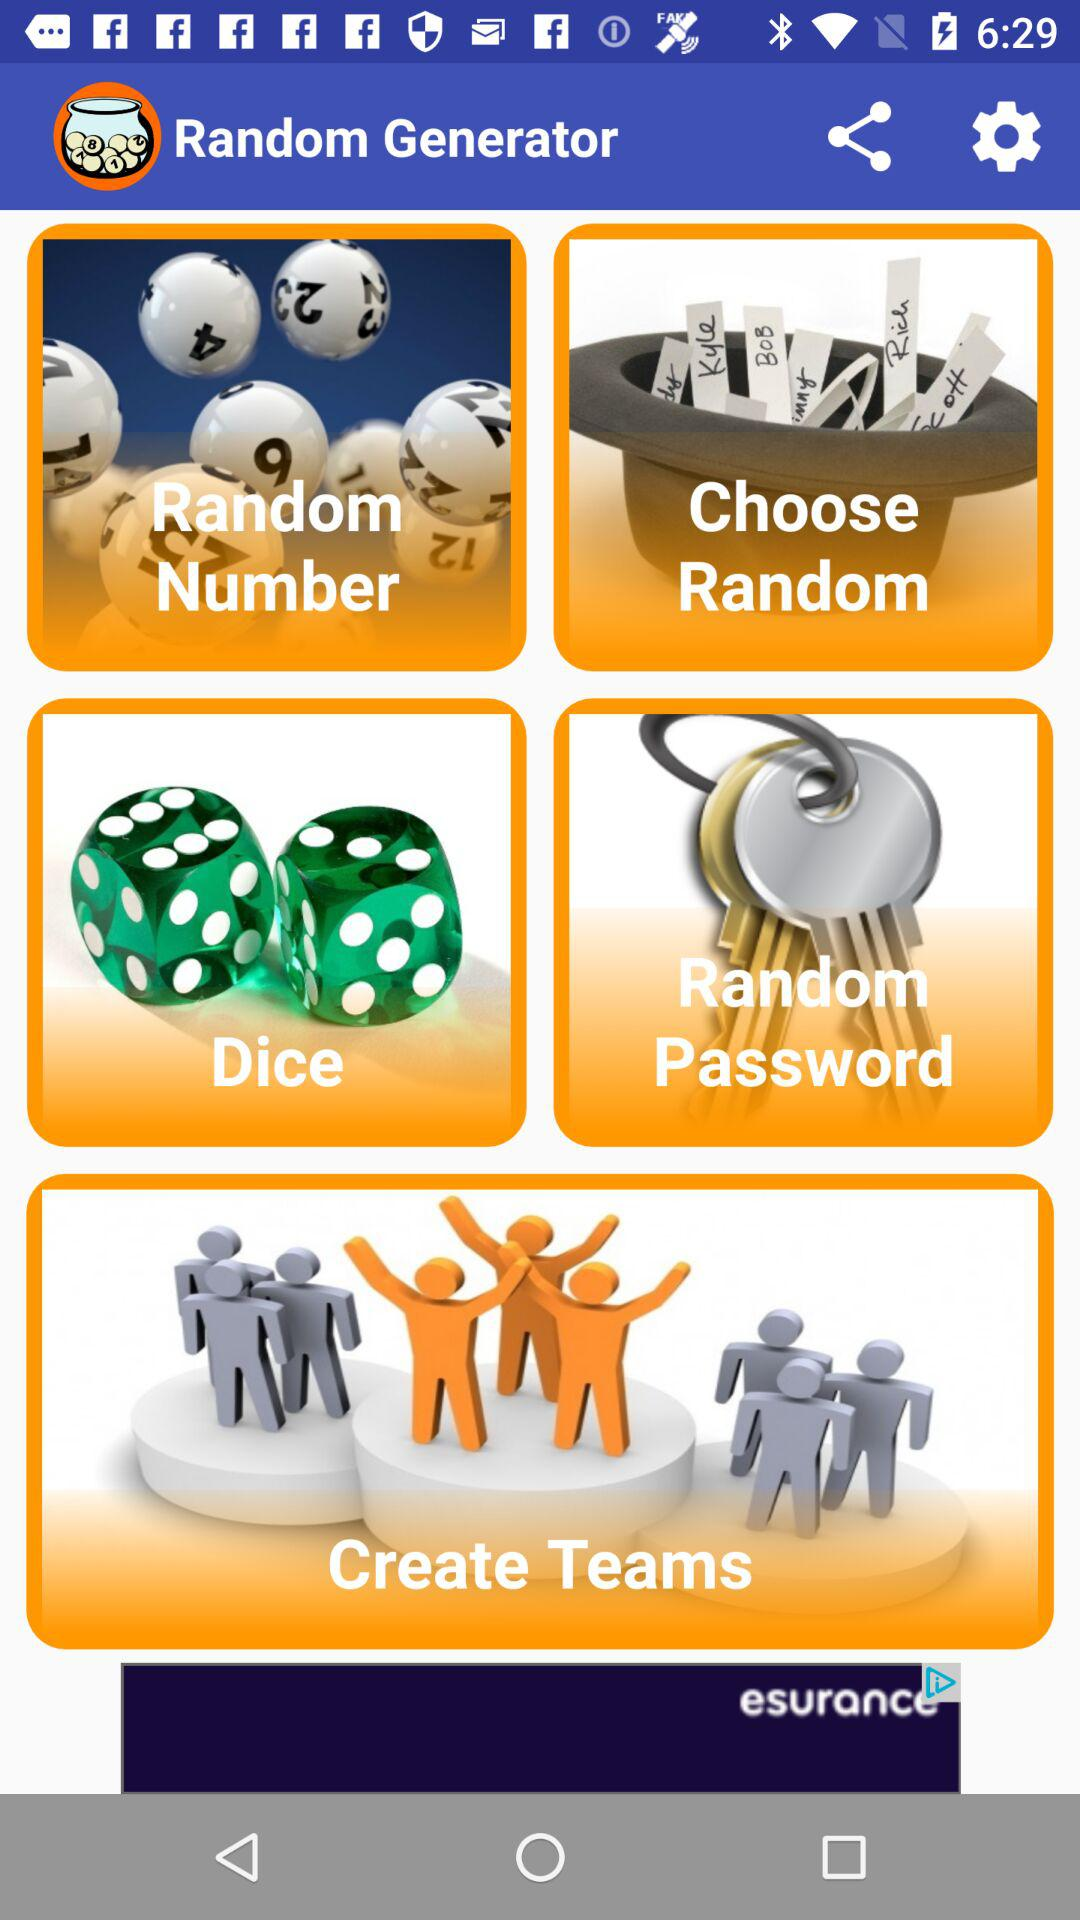What is the name of the application? The name of the application is "Random Generator". 